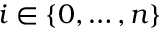Convert formula to latex. <formula><loc_0><loc_0><loc_500><loc_500>i \in \{ 0 , \dots , n \}</formula> 